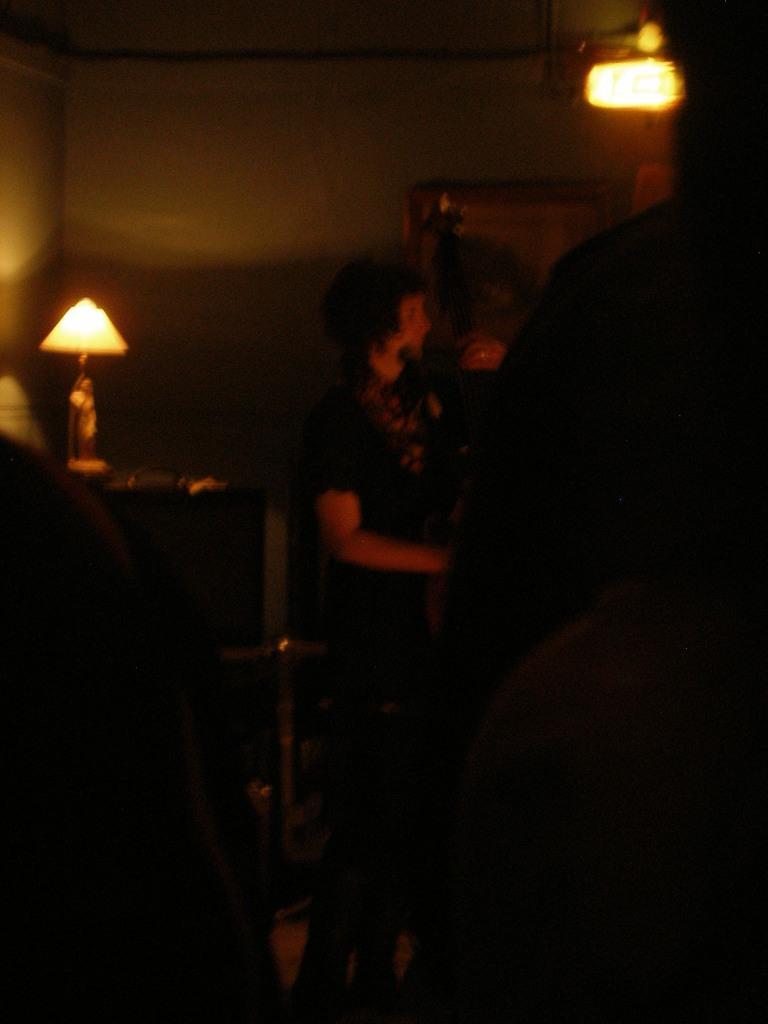How would you summarize this image in a sentence or two? In the picture we can see inside view of the dark room with a person standing near the wall and beside him we can see a table with a lamp on it and into the wall also we can see the light. 